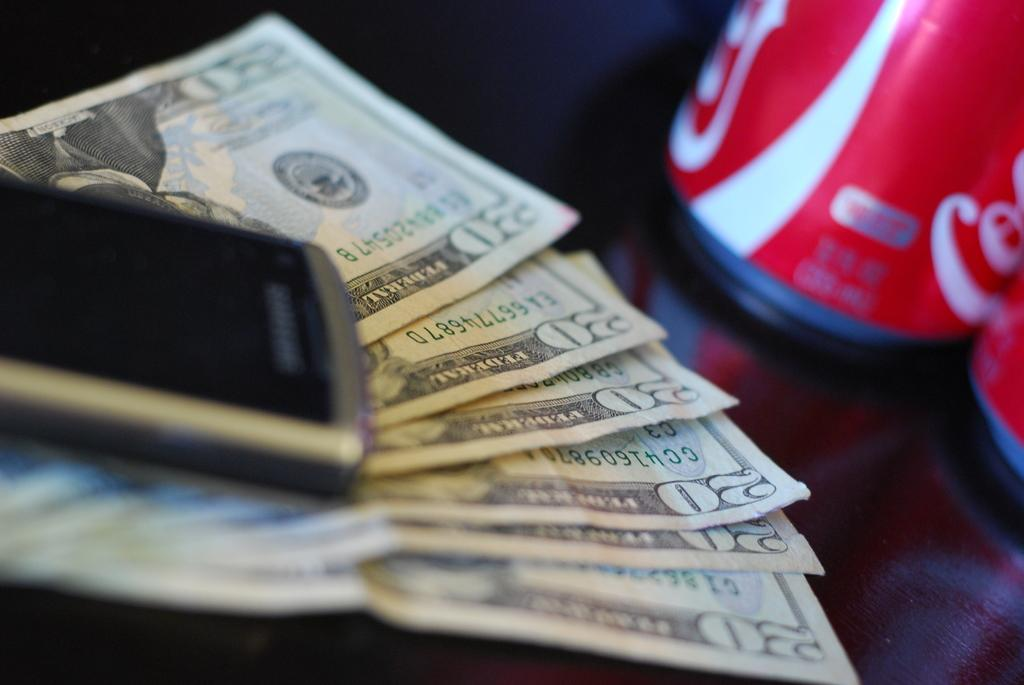Provide a one-sentence caption for the provided image. A cell phone rests on $120 and next to some Coke cans. 